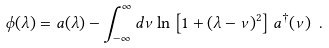<formula> <loc_0><loc_0><loc_500><loc_500>\phi ( \lambda ) = a ( \lambda ) - \int ^ { \infty } _ { - \infty } d \nu \ln \left [ 1 + ( \lambda - \nu ) ^ { 2 } \right ] a ^ { \dagger } ( \nu ) \ .</formula> 